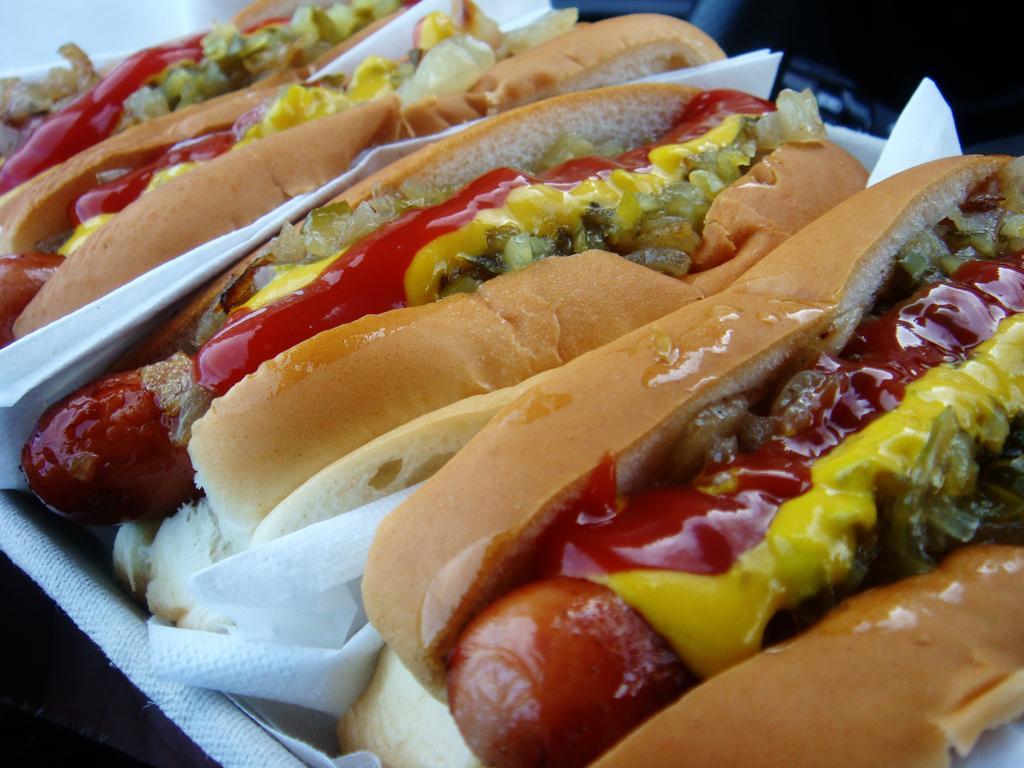In one or two sentences, can you explain what this image depicts? In this picture we can see many burgers on the tray. On the right we can see bread, tomato, ketchup and other food item. Beside that there is a tissue paper. 